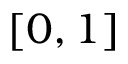Convert formula to latex. <formula><loc_0><loc_0><loc_500><loc_500>[ 0 , 1 ]</formula> 